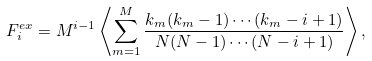Convert formula to latex. <formula><loc_0><loc_0><loc_500><loc_500>F ^ { e x } _ { i } = M ^ { i - 1 } \left \langle \sum _ { m = 1 } ^ { M } \frac { k _ { m } ( k _ { m } - 1 ) \cdots ( k _ { m } - i + 1 ) } { N ( N - 1 ) \cdots ( N - i + 1 ) } \right \rangle ,</formula> 